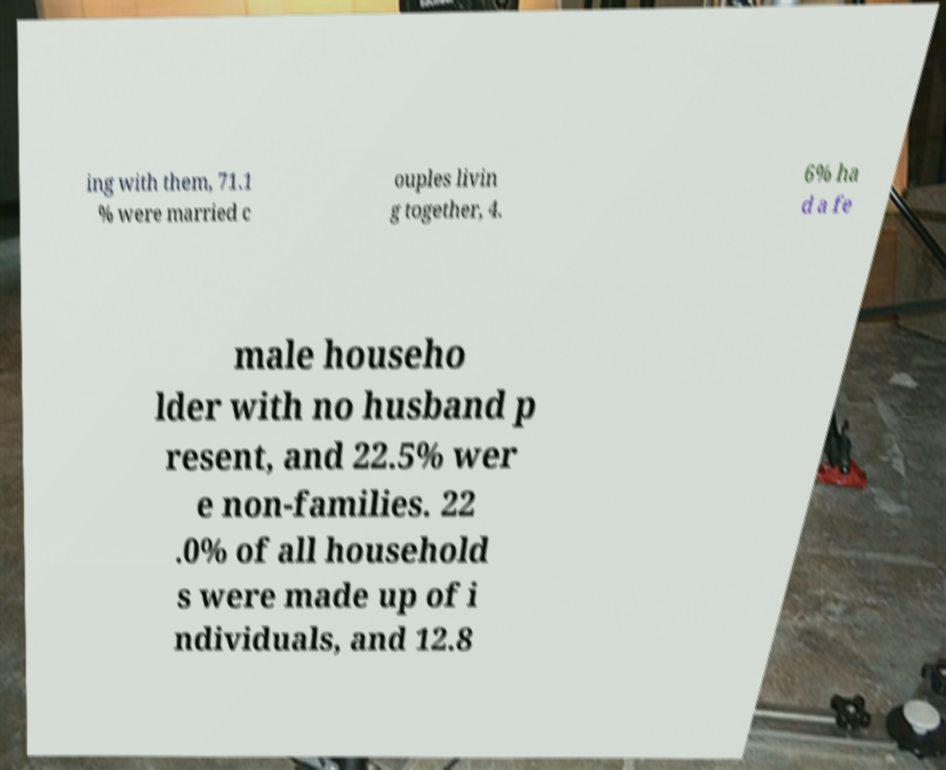There's text embedded in this image that I need extracted. Can you transcribe it verbatim? ing with them, 71.1 % were married c ouples livin g together, 4. 6% ha d a fe male househo lder with no husband p resent, and 22.5% wer e non-families. 22 .0% of all household s were made up of i ndividuals, and 12.8 